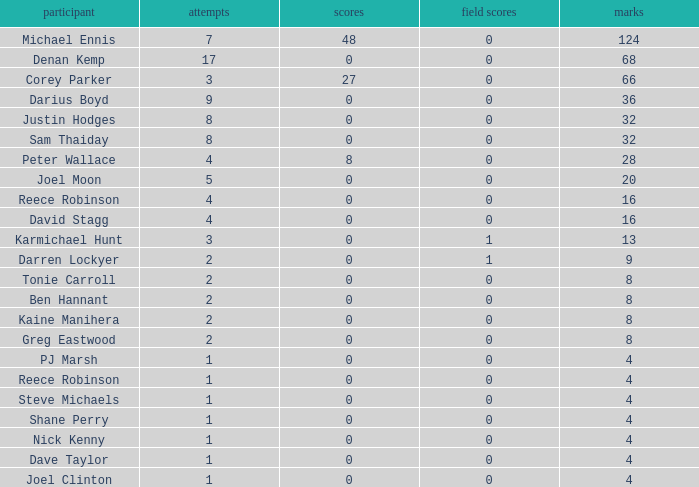How many points did the player with 2 tries and more than 0 field goals have? 9.0. Could you parse the entire table? {'header': ['participant', 'attempts', 'scores', 'field scores', 'marks'], 'rows': [['Michael Ennis', '7', '48', '0', '124'], ['Denan Kemp', '17', '0', '0', '68'], ['Corey Parker', '3', '27', '0', '66'], ['Darius Boyd', '9', '0', '0', '36'], ['Justin Hodges', '8', '0', '0', '32'], ['Sam Thaiday', '8', '0', '0', '32'], ['Peter Wallace', '4', '8', '0', '28'], ['Joel Moon', '5', '0', '0', '20'], ['Reece Robinson', '4', '0', '0', '16'], ['David Stagg', '4', '0', '0', '16'], ['Karmichael Hunt', '3', '0', '1', '13'], ['Darren Lockyer', '2', '0', '1', '9'], ['Tonie Carroll', '2', '0', '0', '8'], ['Ben Hannant', '2', '0', '0', '8'], ['Kaine Manihera', '2', '0', '0', '8'], ['Greg Eastwood', '2', '0', '0', '8'], ['PJ Marsh', '1', '0', '0', '4'], ['Reece Robinson', '1', '0', '0', '4'], ['Steve Michaels', '1', '0', '0', '4'], ['Shane Perry', '1', '0', '0', '4'], ['Nick Kenny', '1', '0', '0', '4'], ['Dave Taylor', '1', '0', '0', '4'], ['Joel Clinton', '1', '0', '0', '4']]} 